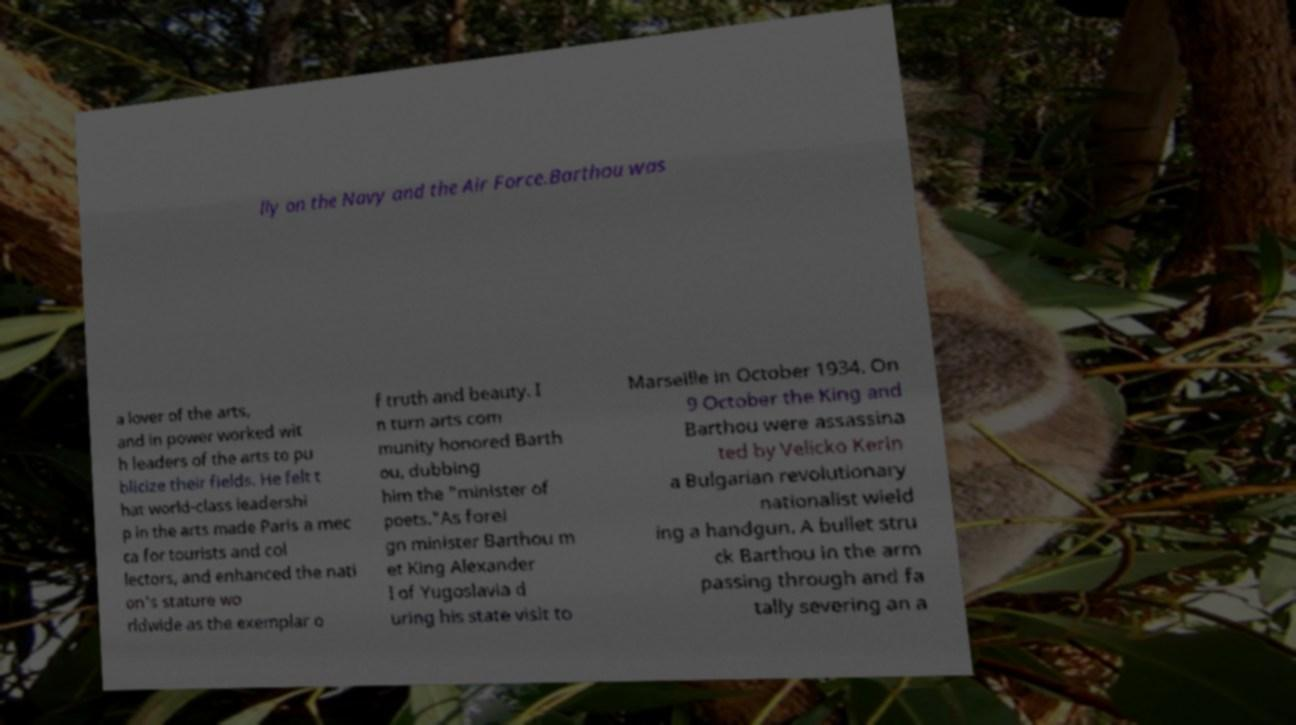For documentation purposes, I need the text within this image transcribed. Could you provide that? lly on the Navy and the Air Force.Barthou was a lover of the arts, and in power worked wit h leaders of the arts to pu blicize their fields. He felt t hat world-class leadershi p in the arts made Paris a mec ca for tourists and col lectors, and enhanced the nati on's stature wo rldwide as the exemplar o f truth and beauty. I n turn arts com munity honored Barth ou, dubbing him the "minister of poets."As forei gn minister Barthou m et King Alexander I of Yugoslavia d uring his state visit to Marseille in October 1934. On 9 October the King and Barthou were assassina ted by Velicko Kerin a Bulgarian revolutionary nationalist wield ing a handgun. A bullet stru ck Barthou in the arm passing through and fa tally severing an a 